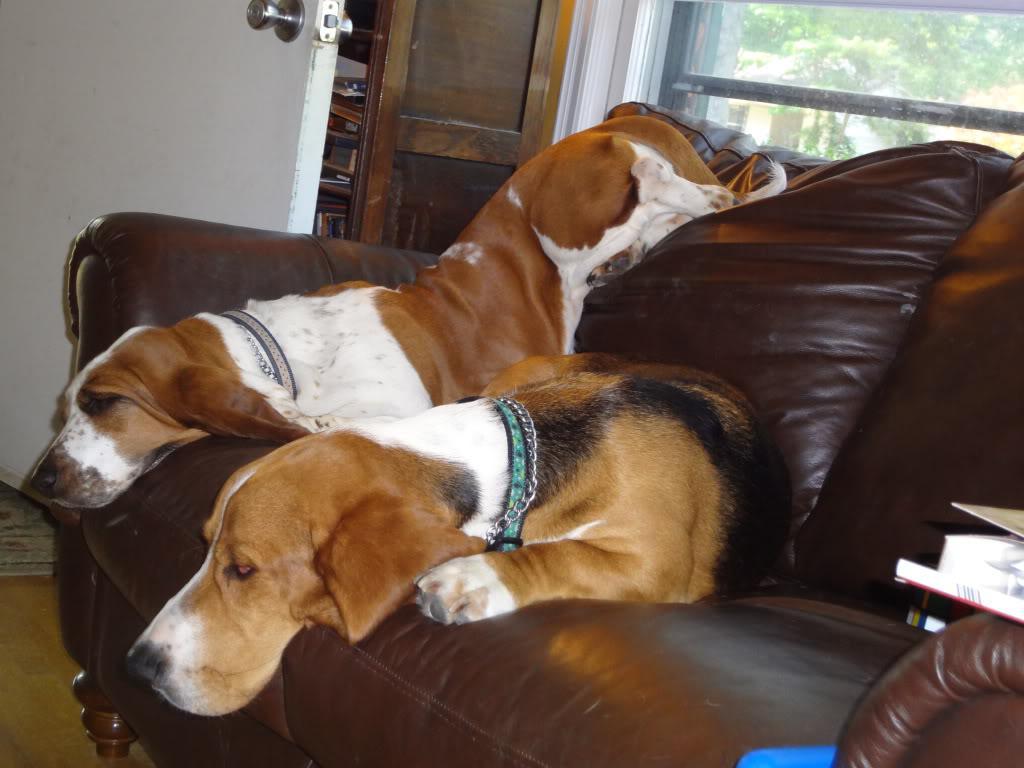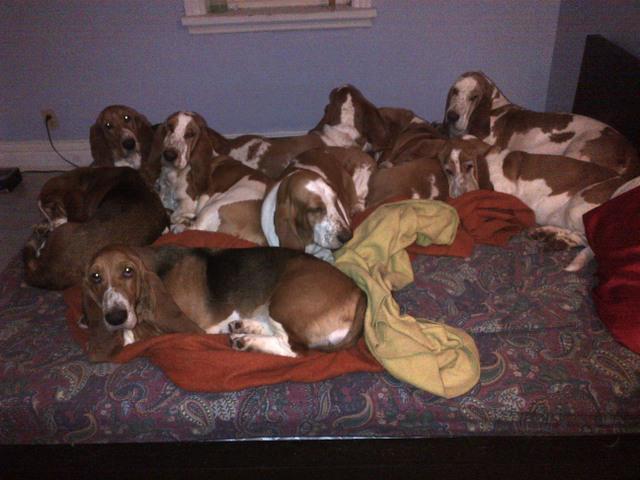The first image is the image on the left, the second image is the image on the right. Examine the images to the left and right. Is the description "There is no more than one sleeping dog in the right image." accurate? Answer yes or no. No. The first image is the image on the left, the second image is the image on the right. Analyze the images presented: Is the assertion "There is a single dog sleeping in the image on the left." valid? Answer yes or no. No. 